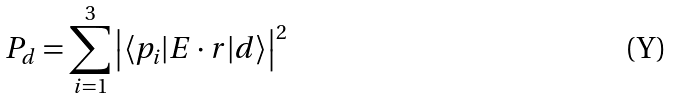<formula> <loc_0><loc_0><loc_500><loc_500>P _ { d } = \sum _ { i = 1 } ^ { 3 } \left | \langle p _ { i } | E \cdot r | d \rangle \right | ^ { 2 }</formula> 